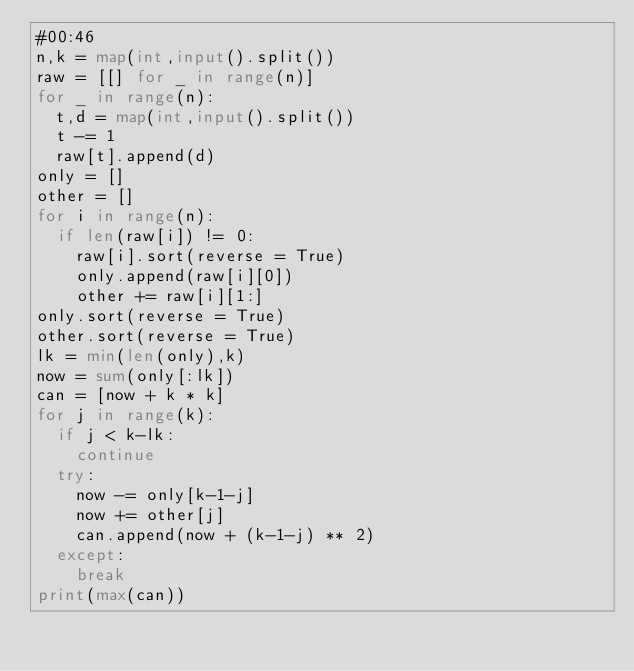<code> <loc_0><loc_0><loc_500><loc_500><_Python_>#00:46
n,k = map(int,input().split())
raw = [[] for _ in range(n)]
for _ in range(n):
  t,d = map(int,input().split())
  t -= 1
  raw[t].append(d)
only = []
other = []
for i in range(n):
  if len(raw[i]) != 0:
    raw[i].sort(reverse = True)
    only.append(raw[i][0])
    other += raw[i][1:]
only.sort(reverse = True)
other.sort(reverse = True)
lk = min(len(only),k)
now = sum(only[:lk])
can = [now + k * k]
for j in range(k):
  if j < k-lk:
    continue
  try:
    now -= only[k-1-j]
    now += other[j]
    can.append(now + (k-1-j) ** 2)
  except:
    break
print(max(can))</code> 